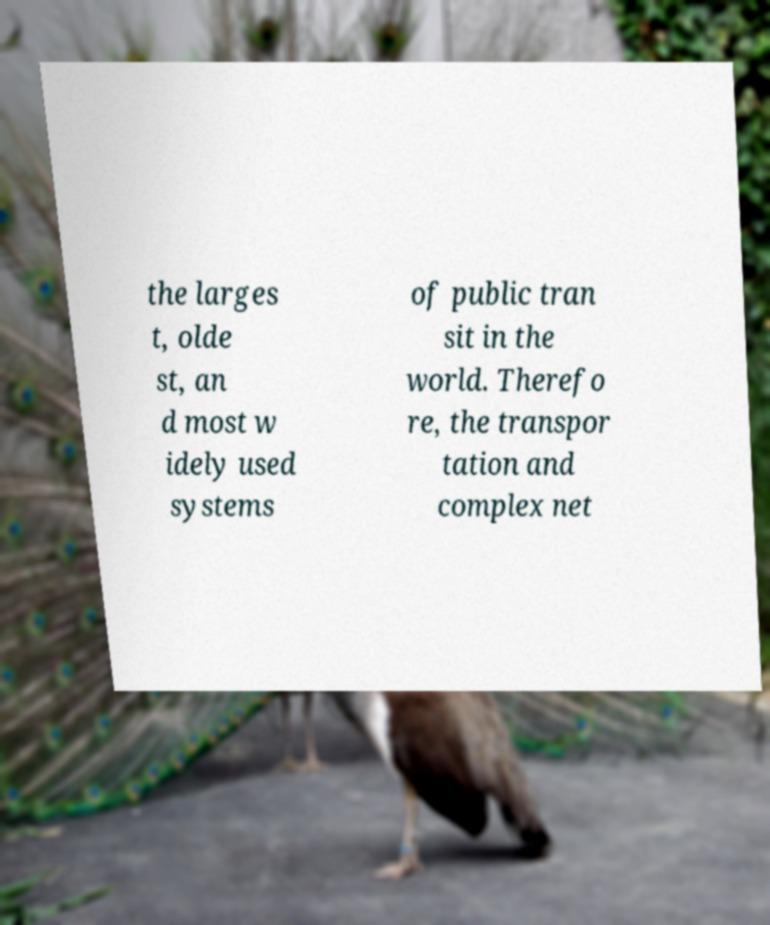I need the written content from this picture converted into text. Can you do that? the larges t, olde st, an d most w idely used systems of public tran sit in the world. Therefo re, the transpor tation and complex net 